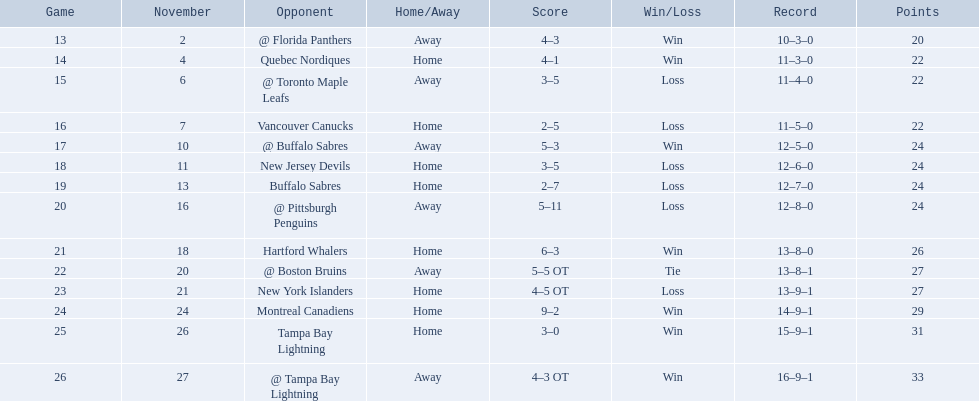Which teams scored 35 points or more in total? Hartford Whalers, @ Boston Bruins, New York Islanders, Montreal Canadiens, Tampa Bay Lightning, @ Tampa Bay Lightning. Of those teams, which team was the only one to score 3-0? Tampa Bay Lightning. Who are all of the teams? @ Florida Panthers, Quebec Nordiques, @ Toronto Maple Leafs, Vancouver Canucks, @ Buffalo Sabres, New Jersey Devils, Buffalo Sabres, @ Pittsburgh Penguins, Hartford Whalers, @ Boston Bruins, New York Islanders, Montreal Canadiens, Tampa Bay Lightning. What games finished in overtime? 22, 23, 26. In game number 23, who did they face? New York Islanders. 